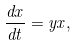<formula> <loc_0><loc_0><loc_500><loc_500>\frac { d x } { d t } = y x ,</formula> 